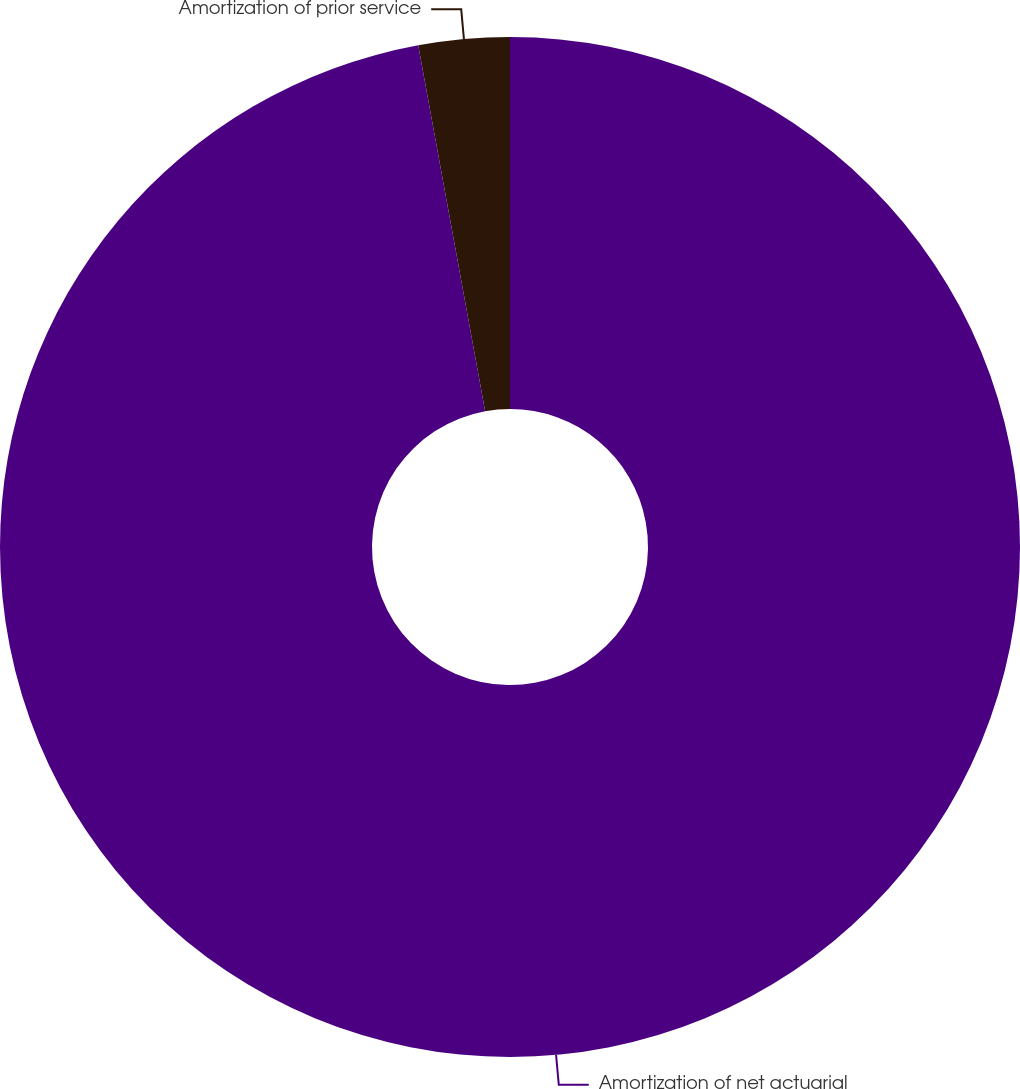Convert chart to OTSL. <chart><loc_0><loc_0><loc_500><loc_500><pie_chart><fcel>Amortization of net actuarial<fcel>Amortization of prior service<nl><fcel>97.12%<fcel>2.88%<nl></chart> 